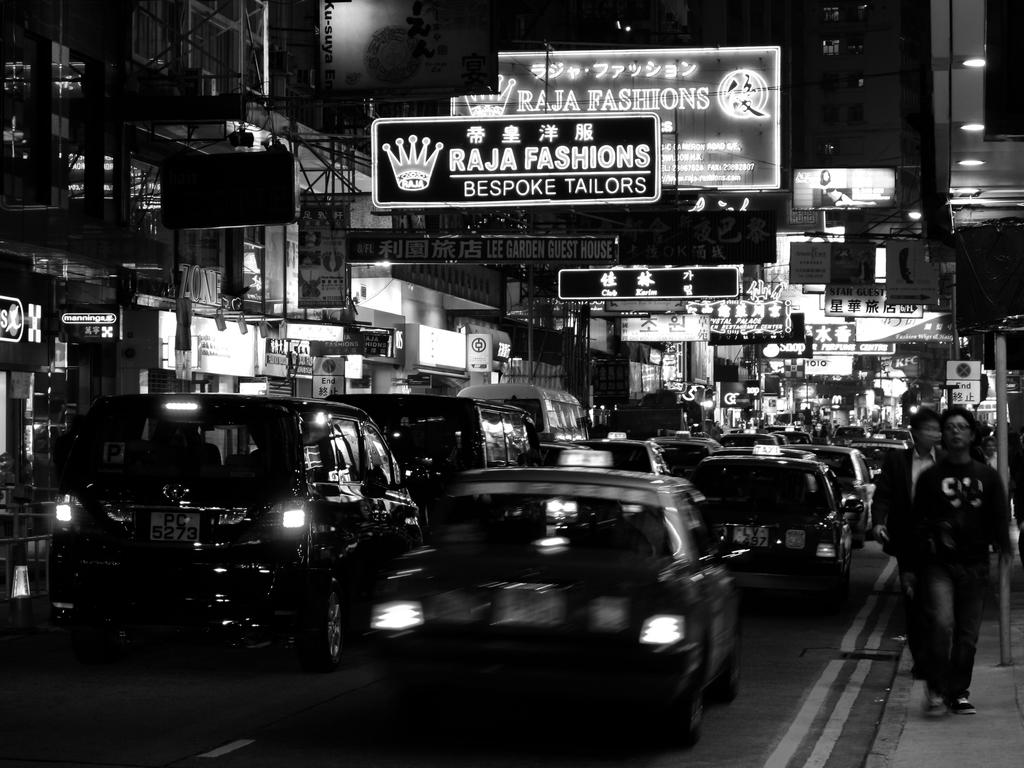<image>
Provide a brief description of the given image. A sign for Raja Fashions features an image of a crown. 